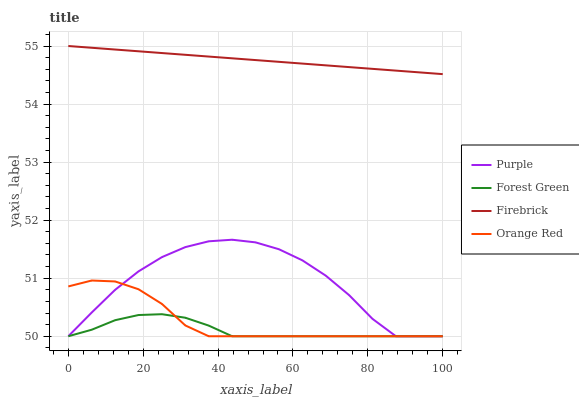Does Forest Green have the minimum area under the curve?
Answer yes or no. Yes. Does Firebrick have the maximum area under the curve?
Answer yes or no. Yes. Does Firebrick have the minimum area under the curve?
Answer yes or no. No. Does Forest Green have the maximum area under the curve?
Answer yes or no. No. Is Firebrick the smoothest?
Answer yes or no. Yes. Is Purple the roughest?
Answer yes or no. Yes. Is Forest Green the smoothest?
Answer yes or no. No. Is Forest Green the roughest?
Answer yes or no. No. Does Purple have the lowest value?
Answer yes or no. Yes. Does Firebrick have the lowest value?
Answer yes or no. No. Does Firebrick have the highest value?
Answer yes or no. Yes. Does Forest Green have the highest value?
Answer yes or no. No. Is Purple less than Firebrick?
Answer yes or no. Yes. Is Firebrick greater than Orange Red?
Answer yes or no. Yes. Does Orange Red intersect Forest Green?
Answer yes or no. Yes. Is Orange Red less than Forest Green?
Answer yes or no. No. Is Orange Red greater than Forest Green?
Answer yes or no. No. Does Purple intersect Firebrick?
Answer yes or no. No. 